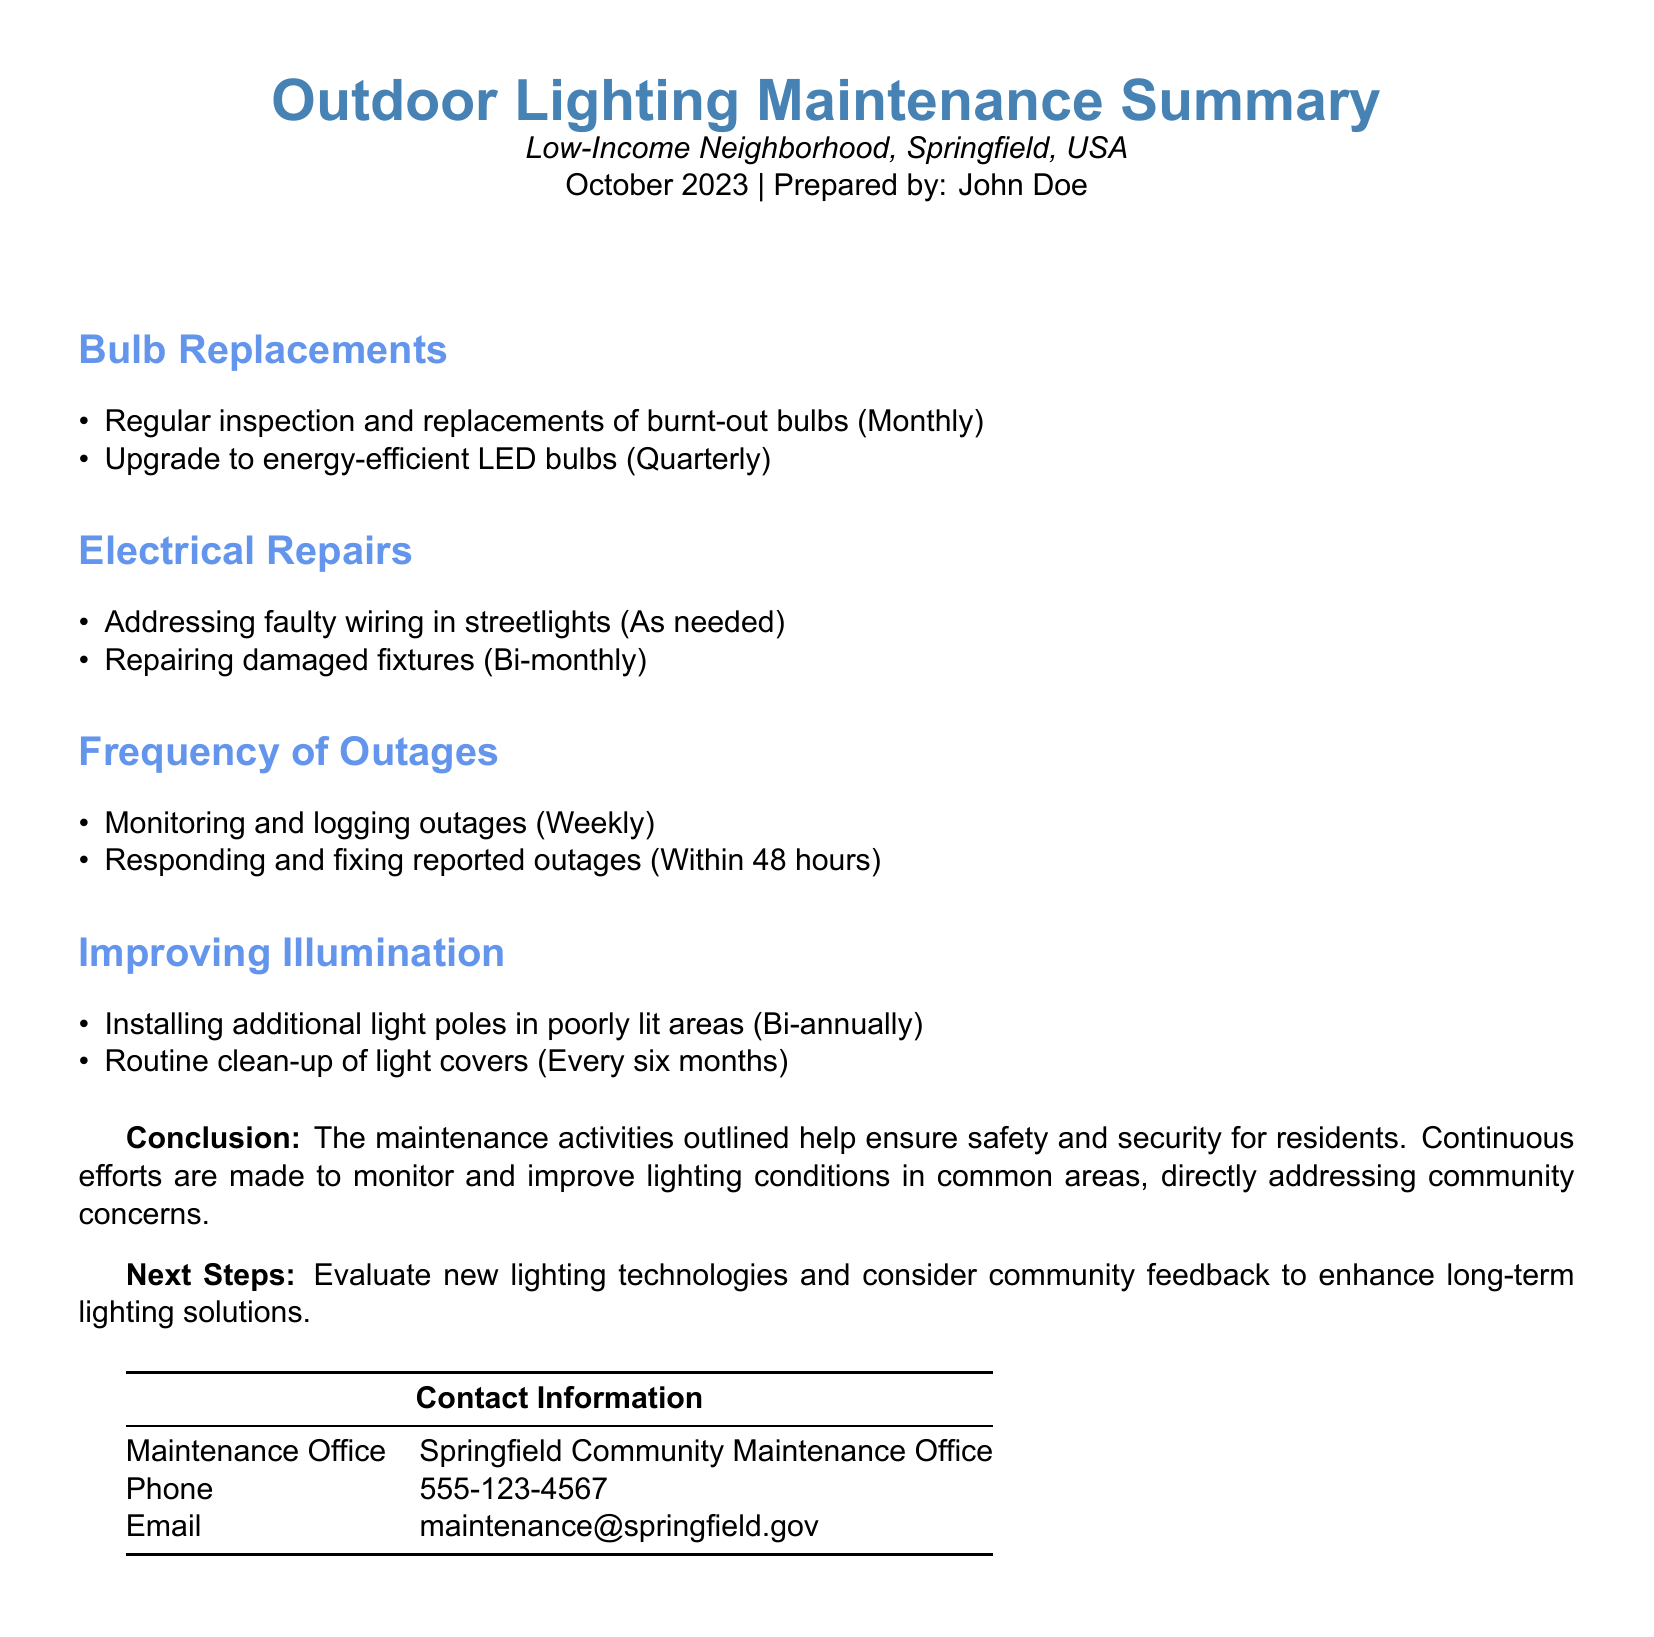What month and year was this summary prepared? The document states it was prepared in October 2023.
Answer: October 2023 How often are burnt-out bulbs inspected and replaced? The document mentions that bulb replacements occur monthly.
Answer: Monthly What type of bulbs are being upgraded in the maintenance activities? The summary specifies that energy-efficient LED bulbs are being used for upgrades.
Answer: LED bulbs How frequently are electrical repairs for damaged fixtures conducted? It is stated that repairs for damaged fixtures are done bi-monthly.
Answer: Bi-monthly What is the response time for fixing reported outages? The summary indicates that outages are responded to and fixed within 48 hours.
Answer: 48 hours How long is the interval for installing additional light poles in poorly lit areas? The document mentions that additional light poles are installed bi-annually.
Answer: Bi-annually What is the main purpose of the maintenance activities outlined in the document? The conclusion states that these activities ensure safety and security for residents.
Answer: Safety and security Who prepared the Outdoor Lighting Maintenance Summary? The document lists John Doe as the preparer of the summary.
Answer: John Doe What is the contact email for the Springfield Community Maintenance Office? The contact information provides the email address for maintenance inquiries.
Answer: maintenance@springfield.gov 